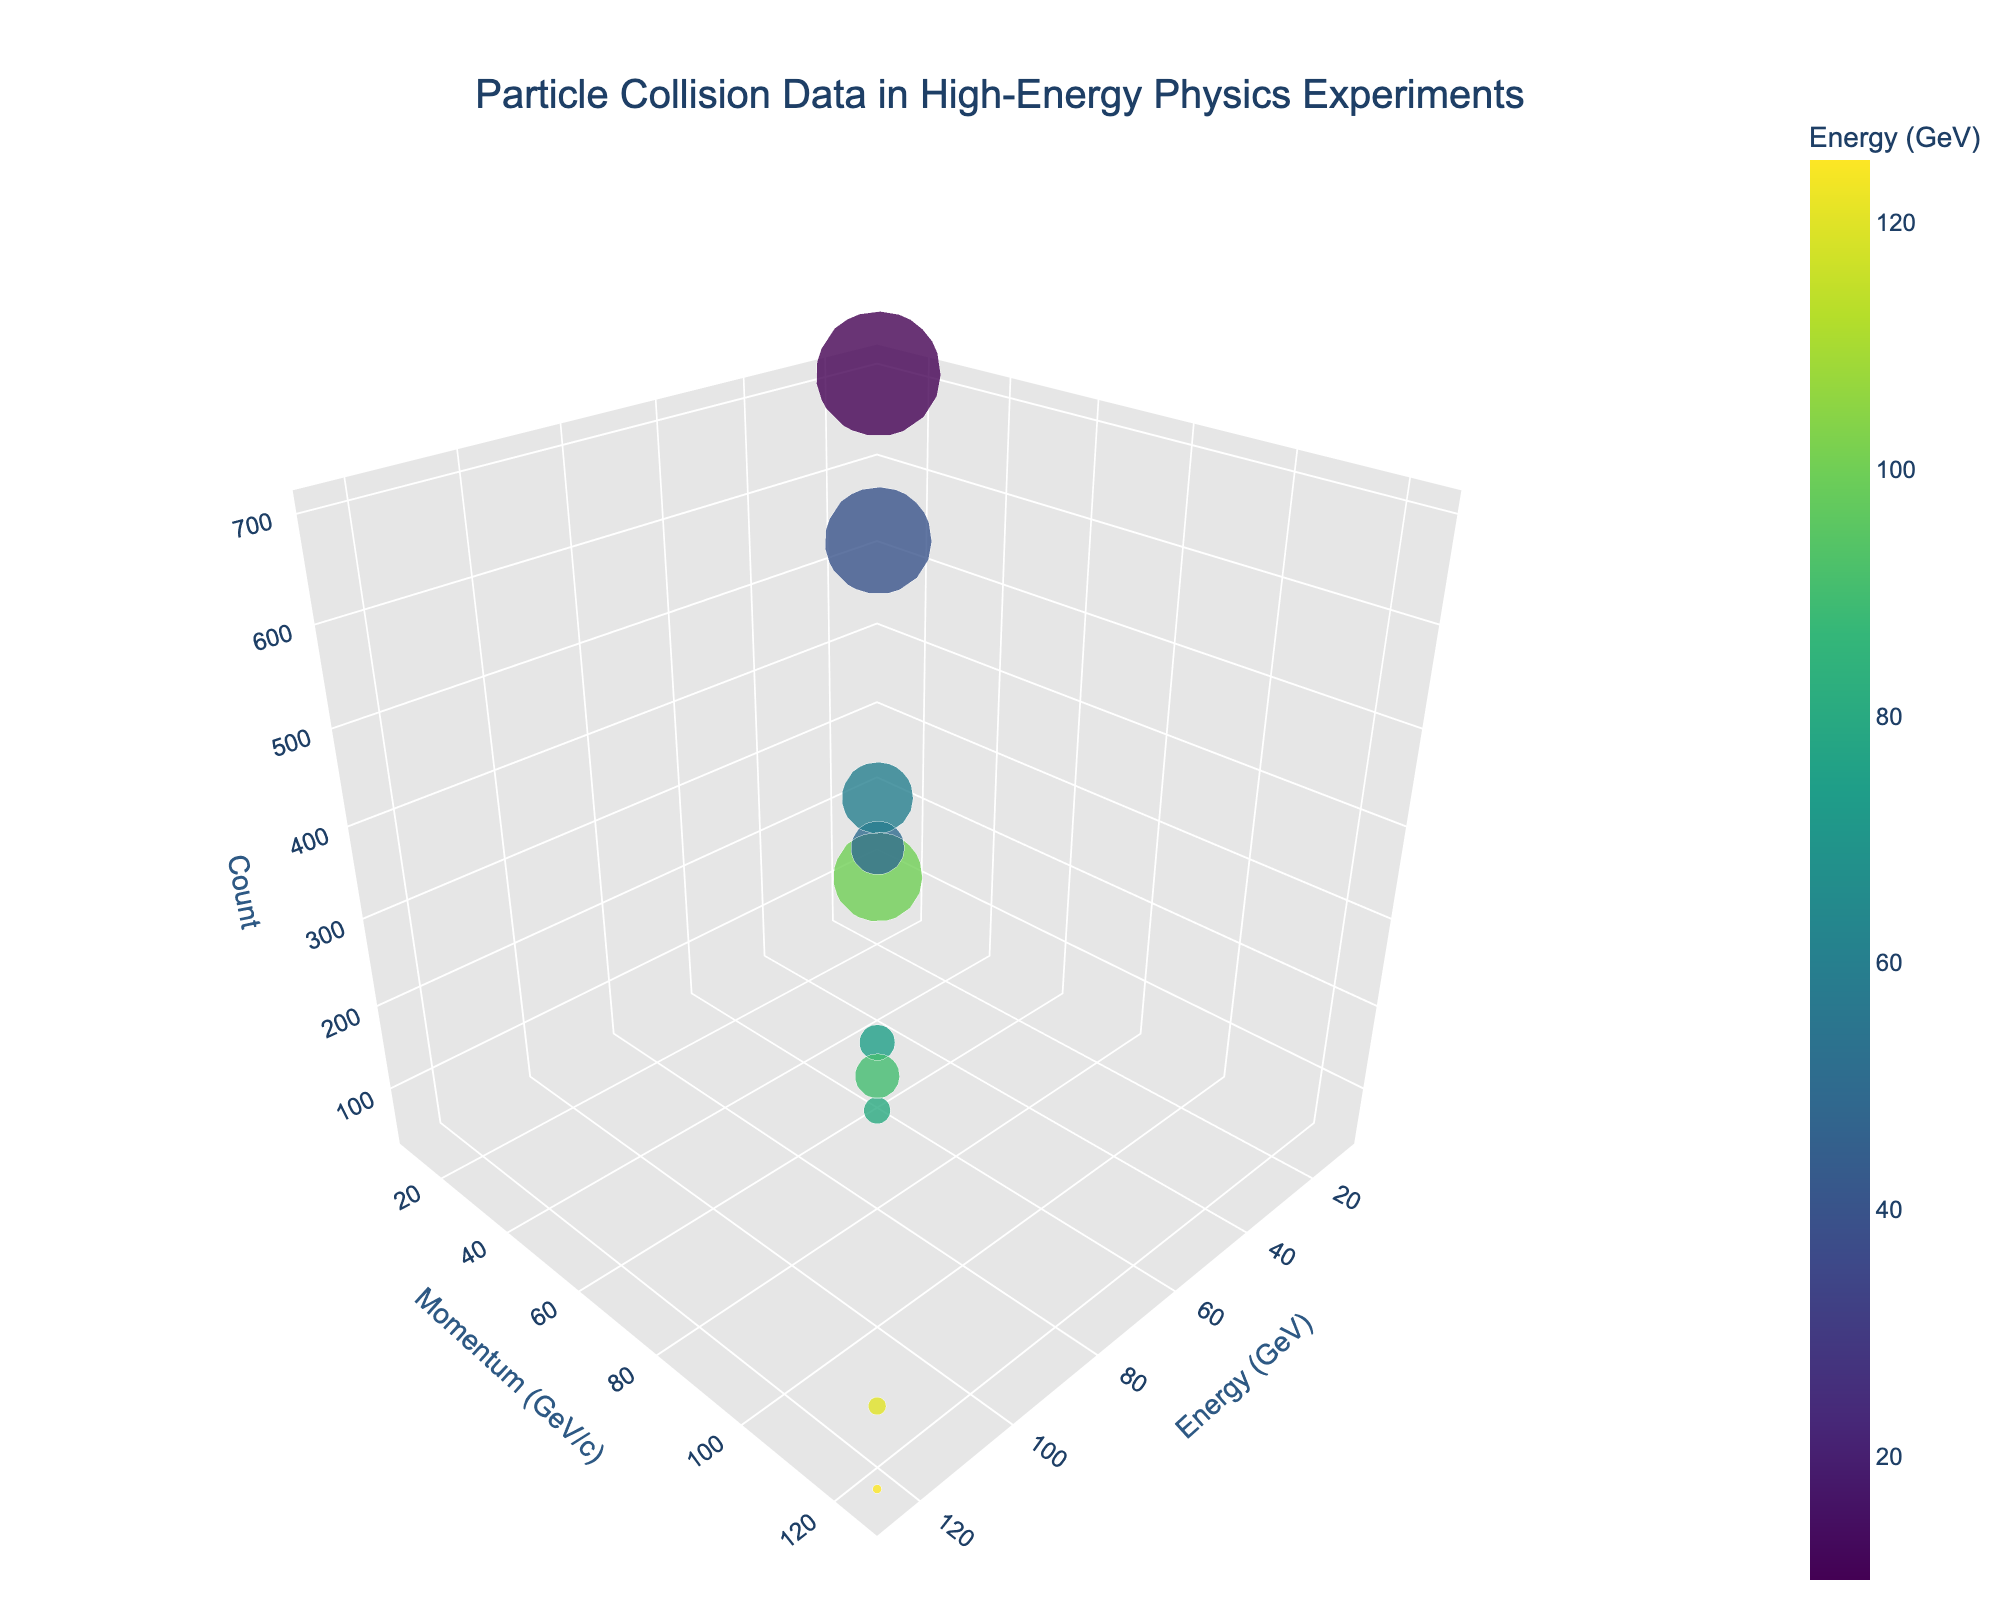What is the title of the figure? The title is usually placed at the top and centered in the figure.
Answer: Particle Collision Data in High-Energy Physics Experiments How many different particles are represented? By counting the unique labels/texts for particles in the figure's legend or hover information, we can determine the number of unique particles.
Answer: 10 Which particle has the highest energy? Identify the particle with the largest value on the x-axis since it represents energy in GeV.
Answer: Higgs boson What is the particle with the smallest momentum value? Identify the particle with the smallest value on the y-axis since it represents momentum in GeV/c.
Answer: Neutrino Which particle has the largest count? Identify the largest value on the z-axis since it represents count. Additionally, the relative size of the bubbles indicates count, with the largest bubble having the greatest count.
Answer: Neutrino Compare the energy and momentum of the Tau and the Higgs boson. Which one has higher values in both metrics? Tau and Higgs boson need to be compared on both the x-axis (Energy) and y-axis (Momentum). Higgs boson has higher values for both metrics.
Answer: Higgs boson What is the average count of the proton and neutron particles? Find the counts of both particles on the z-axis: Proton (500) and Neutron (250). Average is calculated as (500 + 250) / 2.
Answer: 375 Which particle type has a count of exactly 50? By observing the z-axis, the particle with a count of 50 can be identified. Also, the hover information can reveal the count for each particle.
Answer: Higgs boson Which two particles have the closest values of momentum? Compare the y-axis (momentum) values and find the two particles with the smallest difference. Refer to their respective values to make the comparison.
Answer: Proton and Tau What is the sum of counts for all particles with energy greater than 100 GeV? Identify particles with energy values above 100: Proton (500), Tau (100), and Higgs boson (50). Sum of their counts: 500 + 100 + 50.
Answer: 650 